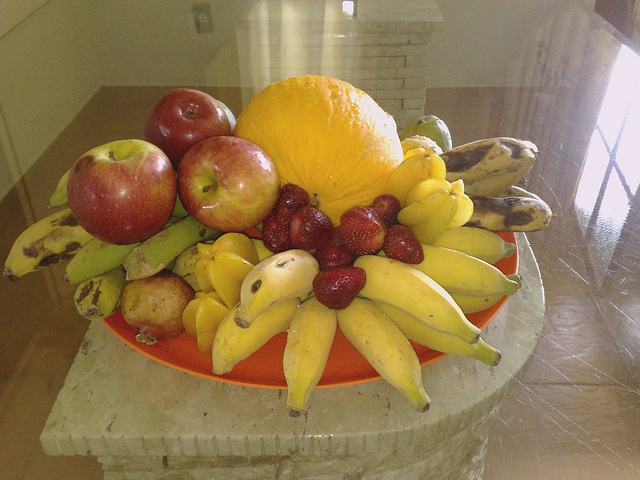Describe the objects in this image and their specific colors. I can see banana in olive, tan, and gold tones, orange in olive, orange, and lightgray tones, apple in olive, maroon, and brown tones, apple in olive, maroon, and salmon tones, and banana in olive and gray tones in this image. 